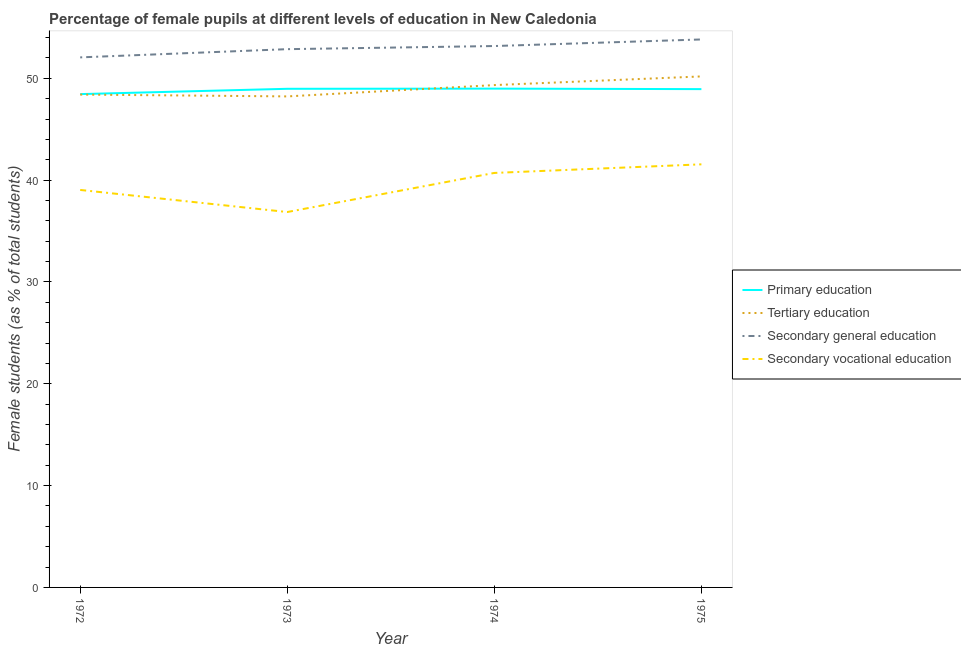How many different coloured lines are there?
Your response must be concise. 4. Is the number of lines equal to the number of legend labels?
Make the answer very short. Yes. What is the percentage of female students in primary education in 1975?
Offer a very short reply. 48.94. Across all years, what is the maximum percentage of female students in primary education?
Provide a short and direct response. 48.99. Across all years, what is the minimum percentage of female students in primary education?
Your answer should be compact. 48.45. In which year was the percentage of female students in primary education maximum?
Your answer should be very brief. 1974. What is the total percentage of female students in primary education in the graph?
Your answer should be compact. 195.35. What is the difference between the percentage of female students in secondary education in 1972 and that in 1975?
Offer a very short reply. -1.76. What is the difference between the percentage of female students in secondary education in 1975 and the percentage of female students in secondary vocational education in 1972?
Your answer should be very brief. 14.78. What is the average percentage of female students in primary education per year?
Give a very brief answer. 48.84. In the year 1972, what is the difference between the percentage of female students in tertiary education and percentage of female students in secondary education?
Your answer should be compact. -3.65. In how many years, is the percentage of female students in tertiary education greater than 30 %?
Make the answer very short. 4. What is the ratio of the percentage of female students in primary education in 1972 to that in 1974?
Keep it short and to the point. 0.99. What is the difference between the highest and the second highest percentage of female students in secondary education?
Your answer should be very brief. 0.65. What is the difference between the highest and the lowest percentage of female students in secondary vocational education?
Provide a succinct answer. 4.68. In how many years, is the percentage of female students in tertiary education greater than the average percentage of female students in tertiary education taken over all years?
Make the answer very short. 2. Is the sum of the percentage of female students in secondary education in 1972 and 1975 greater than the maximum percentage of female students in primary education across all years?
Your answer should be very brief. Yes. Is it the case that in every year, the sum of the percentage of female students in secondary education and percentage of female students in secondary vocational education is greater than the sum of percentage of female students in tertiary education and percentage of female students in primary education?
Offer a terse response. No. Is it the case that in every year, the sum of the percentage of female students in primary education and percentage of female students in tertiary education is greater than the percentage of female students in secondary education?
Your answer should be compact. Yes. Does the percentage of female students in secondary education monotonically increase over the years?
Your answer should be very brief. Yes. Is the percentage of female students in secondary education strictly greater than the percentage of female students in primary education over the years?
Your answer should be very brief. Yes. How many lines are there?
Your response must be concise. 4. How many years are there in the graph?
Give a very brief answer. 4. Are the values on the major ticks of Y-axis written in scientific E-notation?
Provide a succinct answer. No. Does the graph contain grids?
Provide a succinct answer. No. Where does the legend appear in the graph?
Offer a very short reply. Center right. What is the title of the graph?
Provide a succinct answer. Percentage of female pupils at different levels of education in New Caledonia. Does "Italy" appear as one of the legend labels in the graph?
Ensure brevity in your answer.  No. What is the label or title of the X-axis?
Keep it short and to the point. Year. What is the label or title of the Y-axis?
Provide a short and direct response. Female students (as % of total students). What is the Female students (as % of total students) of Primary education in 1972?
Offer a very short reply. 48.45. What is the Female students (as % of total students) in Tertiary education in 1972?
Provide a succinct answer. 48.4. What is the Female students (as % of total students) in Secondary general education in 1972?
Offer a very short reply. 52.06. What is the Female students (as % of total students) of Secondary vocational education in 1972?
Keep it short and to the point. 39.04. What is the Female students (as % of total students) in Primary education in 1973?
Provide a short and direct response. 48.97. What is the Female students (as % of total students) in Tertiary education in 1973?
Your answer should be very brief. 48.22. What is the Female students (as % of total students) in Secondary general education in 1973?
Offer a very short reply. 52.87. What is the Female students (as % of total students) of Secondary vocational education in 1973?
Provide a short and direct response. 36.87. What is the Female students (as % of total students) of Primary education in 1974?
Offer a terse response. 48.99. What is the Female students (as % of total students) of Tertiary education in 1974?
Your answer should be very brief. 49.34. What is the Female students (as % of total students) of Secondary general education in 1974?
Offer a very short reply. 53.17. What is the Female students (as % of total students) of Secondary vocational education in 1974?
Ensure brevity in your answer.  40.71. What is the Female students (as % of total students) in Primary education in 1975?
Your answer should be very brief. 48.94. What is the Female students (as % of total students) of Tertiary education in 1975?
Offer a very short reply. 50.19. What is the Female students (as % of total students) in Secondary general education in 1975?
Your answer should be very brief. 53.82. What is the Female students (as % of total students) of Secondary vocational education in 1975?
Ensure brevity in your answer.  41.55. Across all years, what is the maximum Female students (as % of total students) of Primary education?
Provide a short and direct response. 48.99. Across all years, what is the maximum Female students (as % of total students) in Tertiary education?
Make the answer very short. 50.19. Across all years, what is the maximum Female students (as % of total students) in Secondary general education?
Make the answer very short. 53.82. Across all years, what is the maximum Female students (as % of total students) of Secondary vocational education?
Give a very brief answer. 41.55. Across all years, what is the minimum Female students (as % of total students) in Primary education?
Your response must be concise. 48.45. Across all years, what is the minimum Female students (as % of total students) in Tertiary education?
Offer a very short reply. 48.22. Across all years, what is the minimum Female students (as % of total students) in Secondary general education?
Provide a short and direct response. 52.06. Across all years, what is the minimum Female students (as % of total students) in Secondary vocational education?
Offer a terse response. 36.87. What is the total Female students (as % of total students) of Primary education in the graph?
Provide a succinct answer. 195.35. What is the total Female students (as % of total students) of Tertiary education in the graph?
Give a very brief answer. 196.16. What is the total Female students (as % of total students) in Secondary general education in the graph?
Keep it short and to the point. 211.91. What is the total Female students (as % of total students) of Secondary vocational education in the graph?
Give a very brief answer. 158.17. What is the difference between the Female students (as % of total students) in Primary education in 1972 and that in 1973?
Make the answer very short. -0.52. What is the difference between the Female students (as % of total students) in Tertiary education in 1972 and that in 1973?
Your response must be concise. 0.18. What is the difference between the Female students (as % of total students) of Secondary general education in 1972 and that in 1973?
Provide a short and direct response. -0.81. What is the difference between the Female students (as % of total students) of Secondary vocational education in 1972 and that in 1973?
Make the answer very short. 2.17. What is the difference between the Female students (as % of total students) of Primary education in 1972 and that in 1974?
Make the answer very short. -0.54. What is the difference between the Female students (as % of total students) of Tertiary education in 1972 and that in 1974?
Offer a terse response. -0.93. What is the difference between the Female students (as % of total students) in Secondary general education in 1972 and that in 1974?
Provide a short and direct response. -1.11. What is the difference between the Female students (as % of total students) in Secondary vocational education in 1972 and that in 1974?
Provide a short and direct response. -1.67. What is the difference between the Female students (as % of total students) of Primary education in 1972 and that in 1975?
Provide a succinct answer. -0.49. What is the difference between the Female students (as % of total students) of Tertiary education in 1972 and that in 1975?
Offer a very short reply. -1.78. What is the difference between the Female students (as % of total students) of Secondary general education in 1972 and that in 1975?
Make the answer very short. -1.76. What is the difference between the Female students (as % of total students) of Secondary vocational education in 1972 and that in 1975?
Your answer should be very brief. -2.51. What is the difference between the Female students (as % of total students) in Primary education in 1973 and that in 1974?
Ensure brevity in your answer.  -0.02. What is the difference between the Female students (as % of total students) of Tertiary education in 1973 and that in 1974?
Ensure brevity in your answer.  -1.11. What is the difference between the Female students (as % of total students) of Secondary general education in 1973 and that in 1974?
Your answer should be very brief. -0.31. What is the difference between the Female students (as % of total students) of Secondary vocational education in 1973 and that in 1974?
Your response must be concise. -3.84. What is the difference between the Female students (as % of total students) of Primary education in 1973 and that in 1975?
Make the answer very short. 0.03. What is the difference between the Female students (as % of total students) of Tertiary education in 1973 and that in 1975?
Ensure brevity in your answer.  -1.96. What is the difference between the Female students (as % of total students) in Secondary general education in 1973 and that in 1975?
Your answer should be compact. -0.95. What is the difference between the Female students (as % of total students) of Secondary vocational education in 1973 and that in 1975?
Your answer should be compact. -4.68. What is the difference between the Female students (as % of total students) of Primary education in 1974 and that in 1975?
Offer a very short reply. 0.05. What is the difference between the Female students (as % of total students) of Tertiary education in 1974 and that in 1975?
Your answer should be compact. -0.85. What is the difference between the Female students (as % of total students) in Secondary general education in 1974 and that in 1975?
Your answer should be very brief. -0.65. What is the difference between the Female students (as % of total students) of Secondary vocational education in 1974 and that in 1975?
Keep it short and to the point. -0.84. What is the difference between the Female students (as % of total students) of Primary education in 1972 and the Female students (as % of total students) of Tertiary education in 1973?
Your answer should be very brief. 0.23. What is the difference between the Female students (as % of total students) in Primary education in 1972 and the Female students (as % of total students) in Secondary general education in 1973?
Your response must be concise. -4.41. What is the difference between the Female students (as % of total students) of Primary education in 1972 and the Female students (as % of total students) of Secondary vocational education in 1973?
Offer a terse response. 11.58. What is the difference between the Female students (as % of total students) of Tertiary education in 1972 and the Female students (as % of total students) of Secondary general education in 1973?
Make the answer very short. -4.46. What is the difference between the Female students (as % of total students) of Tertiary education in 1972 and the Female students (as % of total students) of Secondary vocational education in 1973?
Make the answer very short. 11.53. What is the difference between the Female students (as % of total students) of Secondary general education in 1972 and the Female students (as % of total students) of Secondary vocational education in 1973?
Your response must be concise. 15.19. What is the difference between the Female students (as % of total students) in Primary education in 1972 and the Female students (as % of total students) in Tertiary education in 1974?
Give a very brief answer. -0.89. What is the difference between the Female students (as % of total students) in Primary education in 1972 and the Female students (as % of total students) in Secondary general education in 1974?
Ensure brevity in your answer.  -4.72. What is the difference between the Female students (as % of total students) of Primary education in 1972 and the Female students (as % of total students) of Secondary vocational education in 1974?
Ensure brevity in your answer.  7.74. What is the difference between the Female students (as % of total students) of Tertiary education in 1972 and the Female students (as % of total students) of Secondary general education in 1974?
Give a very brief answer. -4.77. What is the difference between the Female students (as % of total students) of Tertiary education in 1972 and the Female students (as % of total students) of Secondary vocational education in 1974?
Ensure brevity in your answer.  7.7. What is the difference between the Female students (as % of total students) in Secondary general education in 1972 and the Female students (as % of total students) in Secondary vocational education in 1974?
Your answer should be compact. 11.35. What is the difference between the Female students (as % of total students) of Primary education in 1972 and the Female students (as % of total students) of Tertiary education in 1975?
Your answer should be compact. -1.74. What is the difference between the Female students (as % of total students) of Primary education in 1972 and the Female students (as % of total students) of Secondary general education in 1975?
Offer a very short reply. -5.37. What is the difference between the Female students (as % of total students) in Primary education in 1972 and the Female students (as % of total students) in Secondary vocational education in 1975?
Your answer should be compact. 6.9. What is the difference between the Female students (as % of total students) in Tertiary education in 1972 and the Female students (as % of total students) in Secondary general education in 1975?
Give a very brief answer. -5.41. What is the difference between the Female students (as % of total students) in Tertiary education in 1972 and the Female students (as % of total students) in Secondary vocational education in 1975?
Provide a succinct answer. 6.85. What is the difference between the Female students (as % of total students) in Secondary general education in 1972 and the Female students (as % of total students) in Secondary vocational education in 1975?
Keep it short and to the point. 10.5. What is the difference between the Female students (as % of total students) in Primary education in 1973 and the Female students (as % of total students) in Tertiary education in 1974?
Ensure brevity in your answer.  -0.37. What is the difference between the Female students (as % of total students) of Primary education in 1973 and the Female students (as % of total students) of Secondary general education in 1974?
Offer a very short reply. -4.2. What is the difference between the Female students (as % of total students) of Primary education in 1973 and the Female students (as % of total students) of Secondary vocational education in 1974?
Give a very brief answer. 8.26. What is the difference between the Female students (as % of total students) in Tertiary education in 1973 and the Female students (as % of total students) in Secondary general education in 1974?
Keep it short and to the point. -4.95. What is the difference between the Female students (as % of total students) of Tertiary education in 1973 and the Female students (as % of total students) of Secondary vocational education in 1974?
Provide a succinct answer. 7.52. What is the difference between the Female students (as % of total students) in Secondary general education in 1973 and the Female students (as % of total students) in Secondary vocational education in 1974?
Give a very brief answer. 12.16. What is the difference between the Female students (as % of total students) in Primary education in 1973 and the Female students (as % of total students) in Tertiary education in 1975?
Your answer should be compact. -1.22. What is the difference between the Female students (as % of total students) in Primary education in 1973 and the Female students (as % of total students) in Secondary general education in 1975?
Keep it short and to the point. -4.85. What is the difference between the Female students (as % of total students) of Primary education in 1973 and the Female students (as % of total students) of Secondary vocational education in 1975?
Your answer should be compact. 7.42. What is the difference between the Female students (as % of total students) in Tertiary education in 1973 and the Female students (as % of total students) in Secondary general education in 1975?
Your answer should be compact. -5.59. What is the difference between the Female students (as % of total students) in Tertiary education in 1973 and the Female students (as % of total students) in Secondary vocational education in 1975?
Make the answer very short. 6.67. What is the difference between the Female students (as % of total students) of Secondary general education in 1973 and the Female students (as % of total students) of Secondary vocational education in 1975?
Your answer should be very brief. 11.31. What is the difference between the Female students (as % of total students) in Primary education in 1974 and the Female students (as % of total students) in Tertiary education in 1975?
Your answer should be very brief. -1.2. What is the difference between the Female students (as % of total students) of Primary education in 1974 and the Female students (as % of total students) of Secondary general education in 1975?
Ensure brevity in your answer.  -4.83. What is the difference between the Female students (as % of total students) of Primary education in 1974 and the Female students (as % of total students) of Secondary vocational education in 1975?
Give a very brief answer. 7.44. What is the difference between the Female students (as % of total students) of Tertiary education in 1974 and the Female students (as % of total students) of Secondary general education in 1975?
Your answer should be compact. -4.48. What is the difference between the Female students (as % of total students) of Tertiary education in 1974 and the Female students (as % of total students) of Secondary vocational education in 1975?
Offer a terse response. 7.78. What is the difference between the Female students (as % of total students) in Secondary general education in 1974 and the Female students (as % of total students) in Secondary vocational education in 1975?
Your response must be concise. 11.62. What is the average Female students (as % of total students) in Primary education per year?
Make the answer very short. 48.84. What is the average Female students (as % of total students) of Tertiary education per year?
Your answer should be compact. 49.04. What is the average Female students (as % of total students) in Secondary general education per year?
Keep it short and to the point. 52.98. What is the average Female students (as % of total students) of Secondary vocational education per year?
Your response must be concise. 39.54. In the year 1972, what is the difference between the Female students (as % of total students) of Primary education and Female students (as % of total students) of Tertiary education?
Give a very brief answer. 0.05. In the year 1972, what is the difference between the Female students (as % of total students) in Primary education and Female students (as % of total students) in Secondary general education?
Your response must be concise. -3.61. In the year 1972, what is the difference between the Female students (as % of total students) in Primary education and Female students (as % of total students) in Secondary vocational education?
Your answer should be compact. 9.41. In the year 1972, what is the difference between the Female students (as % of total students) in Tertiary education and Female students (as % of total students) in Secondary general education?
Offer a terse response. -3.65. In the year 1972, what is the difference between the Female students (as % of total students) in Tertiary education and Female students (as % of total students) in Secondary vocational education?
Offer a very short reply. 9.37. In the year 1972, what is the difference between the Female students (as % of total students) of Secondary general education and Female students (as % of total students) of Secondary vocational education?
Offer a very short reply. 13.02. In the year 1973, what is the difference between the Female students (as % of total students) in Primary education and Female students (as % of total students) in Tertiary education?
Your response must be concise. 0.75. In the year 1973, what is the difference between the Female students (as % of total students) in Primary education and Female students (as % of total students) in Secondary general education?
Give a very brief answer. -3.89. In the year 1973, what is the difference between the Female students (as % of total students) in Primary education and Female students (as % of total students) in Secondary vocational education?
Your response must be concise. 12.1. In the year 1973, what is the difference between the Female students (as % of total students) of Tertiary education and Female students (as % of total students) of Secondary general education?
Offer a terse response. -4.64. In the year 1973, what is the difference between the Female students (as % of total students) in Tertiary education and Female students (as % of total students) in Secondary vocational education?
Provide a succinct answer. 11.36. In the year 1973, what is the difference between the Female students (as % of total students) in Secondary general education and Female students (as % of total students) in Secondary vocational education?
Offer a very short reply. 16. In the year 1974, what is the difference between the Female students (as % of total students) in Primary education and Female students (as % of total students) in Tertiary education?
Offer a terse response. -0.35. In the year 1974, what is the difference between the Female students (as % of total students) in Primary education and Female students (as % of total students) in Secondary general education?
Offer a terse response. -4.18. In the year 1974, what is the difference between the Female students (as % of total students) of Primary education and Female students (as % of total students) of Secondary vocational education?
Provide a short and direct response. 8.28. In the year 1974, what is the difference between the Female students (as % of total students) of Tertiary education and Female students (as % of total students) of Secondary general education?
Your response must be concise. -3.84. In the year 1974, what is the difference between the Female students (as % of total students) of Tertiary education and Female students (as % of total students) of Secondary vocational education?
Offer a terse response. 8.63. In the year 1974, what is the difference between the Female students (as % of total students) of Secondary general education and Female students (as % of total students) of Secondary vocational education?
Ensure brevity in your answer.  12.46. In the year 1975, what is the difference between the Female students (as % of total students) of Primary education and Female students (as % of total students) of Tertiary education?
Ensure brevity in your answer.  -1.25. In the year 1975, what is the difference between the Female students (as % of total students) in Primary education and Female students (as % of total students) in Secondary general education?
Keep it short and to the point. -4.88. In the year 1975, what is the difference between the Female students (as % of total students) in Primary education and Female students (as % of total students) in Secondary vocational education?
Give a very brief answer. 7.39. In the year 1975, what is the difference between the Female students (as % of total students) in Tertiary education and Female students (as % of total students) in Secondary general education?
Keep it short and to the point. -3.63. In the year 1975, what is the difference between the Female students (as % of total students) of Tertiary education and Female students (as % of total students) of Secondary vocational education?
Offer a terse response. 8.63. In the year 1975, what is the difference between the Female students (as % of total students) of Secondary general education and Female students (as % of total students) of Secondary vocational education?
Offer a terse response. 12.27. What is the ratio of the Female students (as % of total students) of Secondary general education in 1972 to that in 1973?
Provide a succinct answer. 0.98. What is the ratio of the Female students (as % of total students) of Secondary vocational education in 1972 to that in 1973?
Offer a terse response. 1.06. What is the ratio of the Female students (as % of total students) in Tertiary education in 1972 to that in 1974?
Keep it short and to the point. 0.98. What is the ratio of the Female students (as % of total students) of Primary education in 1972 to that in 1975?
Your answer should be very brief. 0.99. What is the ratio of the Female students (as % of total students) of Tertiary education in 1972 to that in 1975?
Keep it short and to the point. 0.96. What is the ratio of the Female students (as % of total students) in Secondary general education in 1972 to that in 1975?
Your answer should be very brief. 0.97. What is the ratio of the Female students (as % of total students) of Secondary vocational education in 1972 to that in 1975?
Give a very brief answer. 0.94. What is the ratio of the Female students (as % of total students) of Tertiary education in 1973 to that in 1974?
Offer a terse response. 0.98. What is the ratio of the Female students (as % of total students) in Secondary general education in 1973 to that in 1974?
Offer a terse response. 0.99. What is the ratio of the Female students (as % of total students) in Secondary vocational education in 1973 to that in 1974?
Your response must be concise. 0.91. What is the ratio of the Female students (as % of total students) in Tertiary education in 1973 to that in 1975?
Provide a short and direct response. 0.96. What is the ratio of the Female students (as % of total students) of Secondary general education in 1973 to that in 1975?
Offer a very short reply. 0.98. What is the ratio of the Female students (as % of total students) in Secondary vocational education in 1973 to that in 1975?
Ensure brevity in your answer.  0.89. What is the ratio of the Female students (as % of total students) of Tertiary education in 1974 to that in 1975?
Give a very brief answer. 0.98. What is the ratio of the Female students (as % of total students) of Secondary vocational education in 1974 to that in 1975?
Ensure brevity in your answer.  0.98. What is the difference between the highest and the second highest Female students (as % of total students) in Primary education?
Your response must be concise. 0.02. What is the difference between the highest and the second highest Female students (as % of total students) in Tertiary education?
Provide a succinct answer. 0.85. What is the difference between the highest and the second highest Female students (as % of total students) in Secondary general education?
Ensure brevity in your answer.  0.65. What is the difference between the highest and the second highest Female students (as % of total students) in Secondary vocational education?
Give a very brief answer. 0.84. What is the difference between the highest and the lowest Female students (as % of total students) in Primary education?
Offer a terse response. 0.54. What is the difference between the highest and the lowest Female students (as % of total students) of Tertiary education?
Your response must be concise. 1.96. What is the difference between the highest and the lowest Female students (as % of total students) in Secondary general education?
Your response must be concise. 1.76. What is the difference between the highest and the lowest Female students (as % of total students) in Secondary vocational education?
Make the answer very short. 4.68. 